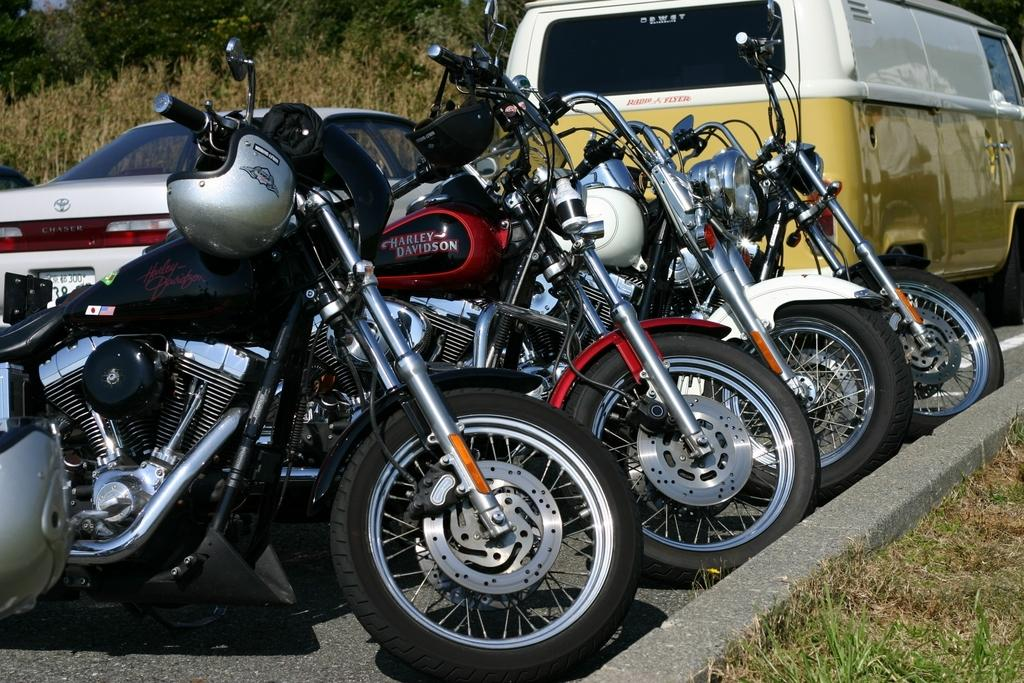What type of transportation can be seen on the road in the image? There are bikes and vehicles on the road in the image. What type of vegetation is visible in the image? There is grass visible in the image. What can be seen in the background of the image? There are trees in the background of the image. What type of wind can be seen blowing through the trees in the image? There is no wind visible in the image; the trees are stationary. 